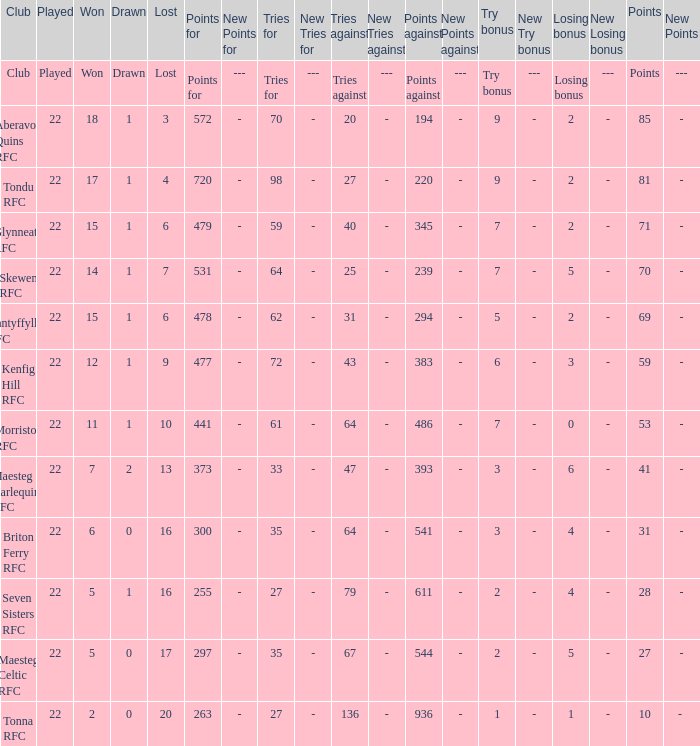What is the value of the points column when the value of the column lost is "lost" Points. Could you parse the entire table as a dict? {'header': ['Club', 'Played', 'Won', 'Drawn', 'Lost', 'Points for', 'New Points for', 'Tries for', 'New Tries for', 'Tries against', 'New Tries against', 'Points against', 'New Points against', 'Try bonus', 'New Try bonus', 'Losing bonus', 'New Losing bonus', 'Points', 'New Points'], 'rows': [['Club', 'Played', 'Won', 'Drawn', 'Lost', 'Points for', '---', 'Tries for', '---', 'Tries against', '---', 'Points against', '---', 'Try bonus', '---', 'Losing bonus', '---', 'Points', '---'], ['Aberavon Quins RFC', '22', '18', '1', '3', '572', '-', '70', '-', '20', '-', '194', '-', '9', '-', '2', '-', '85', '-'], ['Tondu RFC', '22', '17', '1', '4', '720', '-', '98', '-', '27', '-', '220', '-', '9', '-', '2', '-', '81', '-'], ['Glynneath RFC', '22', '15', '1', '6', '479', '-', '59', '-', '40', '-', '345', '-', '7', '-', '2', '-', '71', '-'], ['Skewen RFC', '22', '14', '1', '7', '531', '-', '64', '-', '25', '-', '239', '-', '7', '-', '5', '-', '70', '-'], ['Nantyffyllon RFC', '22', '15', '1', '6', '478', '-', '62', '-', '31', '-', '294', '-', '5', '-', '2', '-', '69', '-'], ['Kenfig Hill RFC', '22', '12', '1', '9', '477', '-', '72', '-', '43', '-', '383', '-', '6', '-', '3', '-', '59', '-'], ['Morriston RFC', '22', '11', '1', '10', '441', '-', '61', '-', '64', '-', '486', '-', '7', '-', '0', '-', '53', '-'], ['Maesteg Harlequins RFC', '22', '7', '2', '13', '373', '-', '33', '-', '47', '-', '393', '-', '3', '-', '6', '-', '41', '-'], ['Briton Ferry RFC', '22', '6', '0', '16', '300', '-', '35', '-', '64', '-', '541', '-', '3', '-', '4', '-', '31', '-'], ['Seven Sisters RFC', '22', '5', '1', '16', '255', '-', '27', '-', '79', '-', '611', '-', '2', '-', '4', '-', '28', '-'], ['Maesteg Celtic RFC', '22', '5', '0', '17', '297', '-', '35', '-', '67', '-', '544', '-', '2', '-', '5', '-', '27', '-'], ['Tonna RFC', '22', '2', '0', '20', '263', '-', '27', '-', '136', '-', '936', '-', '1', '-', '1', '-', '10', '- ']]} 